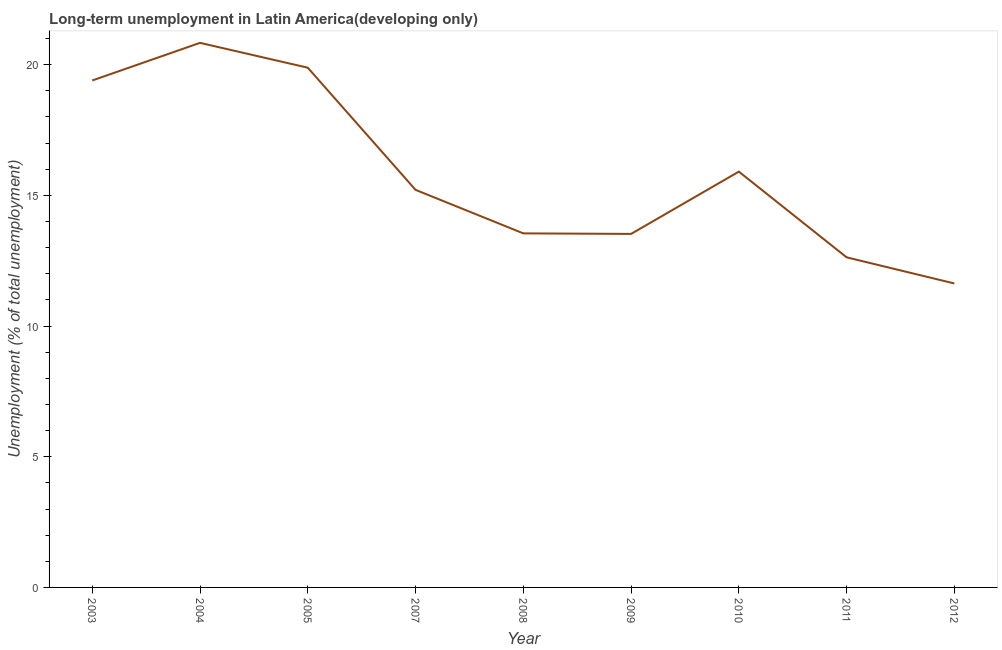What is the long-term unemployment in 2004?
Offer a very short reply. 20.83. Across all years, what is the maximum long-term unemployment?
Offer a terse response. 20.83. Across all years, what is the minimum long-term unemployment?
Provide a succinct answer. 11.63. What is the sum of the long-term unemployment?
Provide a short and direct response. 142.54. What is the difference between the long-term unemployment in 2005 and 2008?
Offer a very short reply. 6.34. What is the average long-term unemployment per year?
Provide a short and direct response. 15.84. What is the median long-term unemployment?
Provide a short and direct response. 15.21. Do a majority of the years between 2011 and 2004 (inclusive) have long-term unemployment greater than 18 %?
Your answer should be very brief. Yes. What is the ratio of the long-term unemployment in 2011 to that in 2012?
Your answer should be compact. 1.09. What is the difference between the highest and the second highest long-term unemployment?
Your answer should be compact. 0.95. What is the difference between the highest and the lowest long-term unemployment?
Your answer should be very brief. 9.2. Does the long-term unemployment monotonically increase over the years?
Make the answer very short. No. How many lines are there?
Give a very brief answer. 1. How many years are there in the graph?
Offer a very short reply. 9. What is the difference between two consecutive major ticks on the Y-axis?
Ensure brevity in your answer.  5. Are the values on the major ticks of Y-axis written in scientific E-notation?
Provide a succinct answer. No. Does the graph contain any zero values?
Provide a short and direct response. No. Does the graph contain grids?
Your response must be concise. No. What is the title of the graph?
Your answer should be very brief. Long-term unemployment in Latin America(developing only). What is the label or title of the X-axis?
Ensure brevity in your answer.  Year. What is the label or title of the Y-axis?
Make the answer very short. Unemployment (% of total unemployment). What is the Unemployment (% of total unemployment) in 2003?
Offer a very short reply. 19.39. What is the Unemployment (% of total unemployment) of 2004?
Your response must be concise. 20.83. What is the Unemployment (% of total unemployment) of 2005?
Keep it short and to the point. 19.88. What is the Unemployment (% of total unemployment) in 2007?
Your answer should be compact. 15.21. What is the Unemployment (% of total unemployment) of 2008?
Your response must be concise. 13.54. What is the Unemployment (% of total unemployment) of 2009?
Keep it short and to the point. 13.52. What is the Unemployment (% of total unemployment) of 2010?
Provide a short and direct response. 15.91. What is the Unemployment (% of total unemployment) in 2011?
Make the answer very short. 12.63. What is the Unemployment (% of total unemployment) of 2012?
Provide a succinct answer. 11.63. What is the difference between the Unemployment (% of total unemployment) in 2003 and 2004?
Ensure brevity in your answer.  -1.44. What is the difference between the Unemployment (% of total unemployment) in 2003 and 2005?
Ensure brevity in your answer.  -0.49. What is the difference between the Unemployment (% of total unemployment) in 2003 and 2007?
Keep it short and to the point. 4.18. What is the difference between the Unemployment (% of total unemployment) in 2003 and 2008?
Provide a succinct answer. 5.85. What is the difference between the Unemployment (% of total unemployment) in 2003 and 2009?
Keep it short and to the point. 5.87. What is the difference between the Unemployment (% of total unemployment) in 2003 and 2010?
Give a very brief answer. 3.49. What is the difference between the Unemployment (% of total unemployment) in 2003 and 2011?
Keep it short and to the point. 6.77. What is the difference between the Unemployment (% of total unemployment) in 2003 and 2012?
Offer a terse response. 7.77. What is the difference between the Unemployment (% of total unemployment) in 2004 and 2005?
Your answer should be very brief. 0.95. What is the difference between the Unemployment (% of total unemployment) in 2004 and 2007?
Your answer should be compact. 5.62. What is the difference between the Unemployment (% of total unemployment) in 2004 and 2008?
Your response must be concise. 7.29. What is the difference between the Unemployment (% of total unemployment) in 2004 and 2009?
Offer a terse response. 7.31. What is the difference between the Unemployment (% of total unemployment) in 2004 and 2010?
Provide a short and direct response. 4.93. What is the difference between the Unemployment (% of total unemployment) in 2004 and 2011?
Your answer should be very brief. 8.2. What is the difference between the Unemployment (% of total unemployment) in 2004 and 2012?
Provide a succinct answer. 9.2. What is the difference between the Unemployment (% of total unemployment) in 2005 and 2007?
Make the answer very short. 4.67. What is the difference between the Unemployment (% of total unemployment) in 2005 and 2008?
Your response must be concise. 6.34. What is the difference between the Unemployment (% of total unemployment) in 2005 and 2009?
Your response must be concise. 6.36. What is the difference between the Unemployment (% of total unemployment) in 2005 and 2010?
Give a very brief answer. 3.98. What is the difference between the Unemployment (% of total unemployment) in 2005 and 2011?
Your response must be concise. 7.25. What is the difference between the Unemployment (% of total unemployment) in 2005 and 2012?
Provide a succinct answer. 8.25. What is the difference between the Unemployment (% of total unemployment) in 2007 and 2008?
Ensure brevity in your answer.  1.66. What is the difference between the Unemployment (% of total unemployment) in 2007 and 2009?
Provide a succinct answer. 1.69. What is the difference between the Unemployment (% of total unemployment) in 2007 and 2010?
Offer a very short reply. -0.7. What is the difference between the Unemployment (% of total unemployment) in 2007 and 2011?
Offer a very short reply. 2.58. What is the difference between the Unemployment (% of total unemployment) in 2007 and 2012?
Your response must be concise. 3.58. What is the difference between the Unemployment (% of total unemployment) in 2008 and 2009?
Keep it short and to the point. 0.02. What is the difference between the Unemployment (% of total unemployment) in 2008 and 2010?
Keep it short and to the point. -2.36. What is the difference between the Unemployment (% of total unemployment) in 2008 and 2011?
Give a very brief answer. 0.92. What is the difference between the Unemployment (% of total unemployment) in 2008 and 2012?
Ensure brevity in your answer.  1.92. What is the difference between the Unemployment (% of total unemployment) in 2009 and 2010?
Your answer should be very brief. -2.38. What is the difference between the Unemployment (% of total unemployment) in 2009 and 2011?
Keep it short and to the point. 0.9. What is the difference between the Unemployment (% of total unemployment) in 2009 and 2012?
Give a very brief answer. 1.9. What is the difference between the Unemployment (% of total unemployment) in 2010 and 2011?
Provide a short and direct response. 3.28. What is the difference between the Unemployment (% of total unemployment) in 2010 and 2012?
Your response must be concise. 4.28. What is the difference between the Unemployment (% of total unemployment) in 2011 and 2012?
Your response must be concise. 1. What is the ratio of the Unemployment (% of total unemployment) in 2003 to that in 2005?
Ensure brevity in your answer.  0.97. What is the ratio of the Unemployment (% of total unemployment) in 2003 to that in 2007?
Your answer should be compact. 1.27. What is the ratio of the Unemployment (% of total unemployment) in 2003 to that in 2008?
Provide a succinct answer. 1.43. What is the ratio of the Unemployment (% of total unemployment) in 2003 to that in 2009?
Your answer should be very brief. 1.43. What is the ratio of the Unemployment (% of total unemployment) in 2003 to that in 2010?
Your answer should be compact. 1.22. What is the ratio of the Unemployment (% of total unemployment) in 2003 to that in 2011?
Keep it short and to the point. 1.54. What is the ratio of the Unemployment (% of total unemployment) in 2003 to that in 2012?
Your response must be concise. 1.67. What is the ratio of the Unemployment (% of total unemployment) in 2004 to that in 2005?
Provide a short and direct response. 1.05. What is the ratio of the Unemployment (% of total unemployment) in 2004 to that in 2007?
Offer a terse response. 1.37. What is the ratio of the Unemployment (% of total unemployment) in 2004 to that in 2008?
Your answer should be compact. 1.54. What is the ratio of the Unemployment (% of total unemployment) in 2004 to that in 2009?
Give a very brief answer. 1.54. What is the ratio of the Unemployment (% of total unemployment) in 2004 to that in 2010?
Provide a short and direct response. 1.31. What is the ratio of the Unemployment (% of total unemployment) in 2004 to that in 2011?
Ensure brevity in your answer.  1.65. What is the ratio of the Unemployment (% of total unemployment) in 2004 to that in 2012?
Provide a succinct answer. 1.79. What is the ratio of the Unemployment (% of total unemployment) in 2005 to that in 2007?
Make the answer very short. 1.31. What is the ratio of the Unemployment (% of total unemployment) in 2005 to that in 2008?
Offer a terse response. 1.47. What is the ratio of the Unemployment (% of total unemployment) in 2005 to that in 2009?
Provide a succinct answer. 1.47. What is the ratio of the Unemployment (% of total unemployment) in 2005 to that in 2010?
Your answer should be compact. 1.25. What is the ratio of the Unemployment (% of total unemployment) in 2005 to that in 2011?
Your response must be concise. 1.57. What is the ratio of the Unemployment (% of total unemployment) in 2005 to that in 2012?
Make the answer very short. 1.71. What is the ratio of the Unemployment (% of total unemployment) in 2007 to that in 2008?
Offer a terse response. 1.12. What is the ratio of the Unemployment (% of total unemployment) in 2007 to that in 2010?
Offer a very short reply. 0.96. What is the ratio of the Unemployment (% of total unemployment) in 2007 to that in 2011?
Give a very brief answer. 1.2. What is the ratio of the Unemployment (% of total unemployment) in 2007 to that in 2012?
Make the answer very short. 1.31. What is the ratio of the Unemployment (% of total unemployment) in 2008 to that in 2010?
Offer a very short reply. 0.85. What is the ratio of the Unemployment (% of total unemployment) in 2008 to that in 2011?
Offer a terse response. 1.07. What is the ratio of the Unemployment (% of total unemployment) in 2008 to that in 2012?
Your answer should be very brief. 1.17. What is the ratio of the Unemployment (% of total unemployment) in 2009 to that in 2011?
Give a very brief answer. 1.07. What is the ratio of the Unemployment (% of total unemployment) in 2009 to that in 2012?
Your response must be concise. 1.16. What is the ratio of the Unemployment (% of total unemployment) in 2010 to that in 2011?
Your response must be concise. 1.26. What is the ratio of the Unemployment (% of total unemployment) in 2010 to that in 2012?
Ensure brevity in your answer.  1.37. What is the ratio of the Unemployment (% of total unemployment) in 2011 to that in 2012?
Offer a terse response. 1.09. 